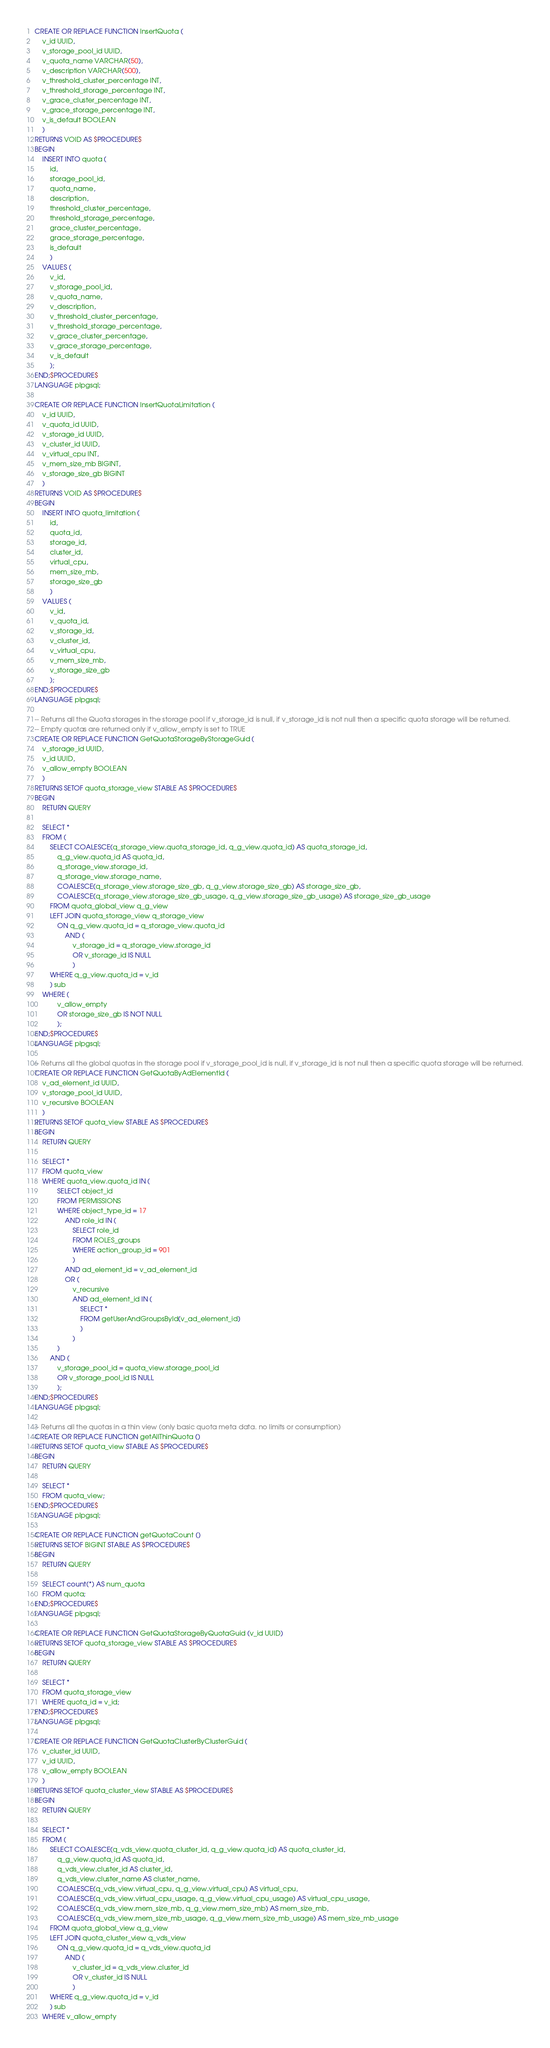<code> <loc_0><loc_0><loc_500><loc_500><_SQL_>

CREATE OR REPLACE FUNCTION InsertQuota (
    v_id UUID,
    v_storage_pool_id UUID,
    v_quota_name VARCHAR(50),
    v_description VARCHAR(500),
    v_threshold_cluster_percentage INT,
    v_threshold_storage_percentage INT,
    v_grace_cluster_percentage INT,
    v_grace_storage_percentage INT,
    v_is_default BOOLEAN
    )
RETURNS VOID AS $PROCEDURE$
BEGIN
    INSERT INTO quota (
        id,
        storage_pool_id,
        quota_name,
        description,
        threshold_cluster_percentage,
        threshold_storage_percentage,
        grace_cluster_percentage,
        grace_storage_percentage,
        is_default
        )
    VALUES (
        v_id,
        v_storage_pool_id,
        v_quota_name,
        v_description,
        v_threshold_cluster_percentage,
        v_threshold_storage_percentage,
        v_grace_cluster_percentage,
        v_grace_storage_percentage,
        v_is_default
        );
END;$PROCEDURE$
LANGUAGE plpgsql;

CREATE OR REPLACE FUNCTION InsertQuotaLimitation (
    v_id UUID,
    v_quota_id UUID,
    v_storage_id UUID,
    v_cluster_id UUID,
    v_virtual_cpu INT,
    v_mem_size_mb BIGINT,
    v_storage_size_gb BIGINT
    )
RETURNS VOID AS $PROCEDURE$
BEGIN
    INSERT INTO quota_limitation (
        id,
        quota_id,
        storage_id,
        cluster_id,
        virtual_cpu,
        mem_size_mb,
        storage_size_gb
        )
    VALUES (
        v_id,
        v_quota_id,
        v_storage_id,
        v_cluster_id,
        v_virtual_cpu,
        v_mem_size_mb,
        v_storage_size_gb
        );
END;$PROCEDURE$
LANGUAGE plpgsql;

-- Returns all the Quota storages in the storage pool if v_storage_id is null, if v_storage_id is not null then a specific quota storage will be returned.
-- Empty quotas are returned only if v_allow_empty is set to TRUE
CREATE OR REPLACE FUNCTION GetQuotaStorageByStorageGuid (
    v_storage_id UUID,
    v_id UUID,
    v_allow_empty BOOLEAN
    )
RETURNS SETOF quota_storage_view STABLE AS $PROCEDURE$
BEGIN
    RETURN QUERY

    SELECT *
    FROM (
        SELECT COALESCE(q_storage_view.quota_storage_id, q_g_view.quota_id) AS quota_storage_id,
            q_g_view.quota_id AS quota_id,
            q_storage_view.storage_id,
            q_storage_view.storage_name,
            COALESCE(q_storage_view.storage_size_gb, q_g_view.storage_size_gb) AS storage_size_gb,
            COALESCE(q_storage_view.storage_size_gb_usage, q_g_view.storage_size_gb_usage) AS storage_size_gb_usage
        FROM quota_global_view q_g_view
        LEFT JOIN quota_storage_view q_storage_view
            ON q_g_view.quota_id = q_storage_view.quota_id
                AND (
                    v_storage_id = q_storage_view.storage_id
                    OR v_storage_id IS NULL
                    )
        WHERE q_g_view.quota_id = v_id
        ) sub
    WHERE (
            v_allow_empty
            OR storage_size_gb IS NOT NULL
            );
END;$PROCEDURE$
LANGUAGE plpgsql;

-- Returns all the global quotas in the storage pool if v_storage_pool_id is null, if v_storage_id is not null then a specific quota storage will be returned.
CREATE OR REPLACE FUNCTION GetQuotaByAdElementId (
    v_ad_element_id UUID,
    v_storage_pool_id UUID,
    v_recursive BOOLEAN
    )
RETURNS SETOF quota_view STABLE AS $PROCEDURE$
BEGIN
    RETURN QUERY

    SELECT *
    FROM quota_view
    WHERE quota_view.quota_id IN (
            SELECT object_id
            FROM PERMISSIONS
            WHERE object_type_id = 17
                AND role_id IN (
                    SELECT role_id
                    FROM ROLES_groups
                    WHERE action_group_id = 901
                    )
                AND ad_element_id = v_ad_element_id
                OR (
                    v_recursive
                    AND ad_element_id IN (
                        SELECT *
                        FROM getUserAndGroupsById(v_ad_element_id)
                        )
                    )
            )
        AND (
            v_storage_pool_id = quota_view.storage_pool_id
            OR v_storage_pool_id IS NULL
            );
END;$PROCEDURE$
LANGUAGE plpgsql;

-- Returns all the quotas in a thin view (only basic quota meta data. no limits or consumption)
CREATE OR REPLACE FUNCTION getAllThinQuota ()
RETURNS SETOF quota_view STABLE AS $PROCEDURE$
BEGIN
    RETURN QUERY

    SELECT *
    FROM quota_view;
END;$PROCEDURE$
LANGUAGE plpgsql;

CREATE OR REPLACE FUNCTION getQuotaCount ()
RETURNS SETOF BIGINT STABLE AS $PROCEDURE$
BEGIN
    RETURN QUERY

    SELECT count(*) AS num_quota
    FROM quota;
END;$PROCEDURE$
LANGUAGE plpgsql;

CREATE OR REPLACE FUNCTION GetQuotaStorageByQuotaGuid (v_id UUID)
RETURNS SETOF quota_storage_view STABLE AS $PROCEDURE$
BEGIN
    RETURN QUERY

    SELECT *
    FROM quota_storage_view
    WHERE quota_id = v_id;
END;$PROCEDURE$
LANGUAGE plpgsql;

CREATE OR REPLACE FUNCTION GetQuotaClusterByClusterGuid (
    v_cluster_id UUID,
    v_id UUID,
    v_allow_empty BOOLEAN
    )
RETURNS SETOF quota_cluster_view STABLE AS $PROCEDURE$
BEGIN
    RETURN QUERY

    SELECT *
    FROM (
        SELECT COALESCE(q_vds_view.quota_cluster_id, q_g_view.quota_id) AS quota_cluster_id,
            q_g_view.quota_id AS quota_id,
            q_vds_view.cluster_id AS cluster_id,
            q_vds_view.cluster_name AS cluster_name,
            COALESCE(q_vds_view.virtual_cpu, q_g_view.virtual_cpu) AS virtual_cpu,
            COALESCE(q_vds_view.virtual_cpu_usage, q_g_view.virtual_cpu_usage) AS virtual_cpu_usage,
            COALESCE(q_vds_view.mem_size_mb, q_g_view.mem_size_mb) AS mem_size_mb,
            COALESCE(q_vds_view.mem_size_mb_usage, q_g_view.mem_size_mb_usage) AS mem_size_mb_usage
        FROM quota_global_view q_g_view
        LEFT JOIN quota_cluster_view q_vds_view
            ON q_g_view.quota_id = q_vds_view.quota_id
                AND (
                    v_cluster_id = q_vds_view.cluster_id
                    OR v_cluster_id IS NULL
                    )
        WHERE q_g_view.quota_id = v_id
        ) sub
    WHERE v_allow_empty</code> 